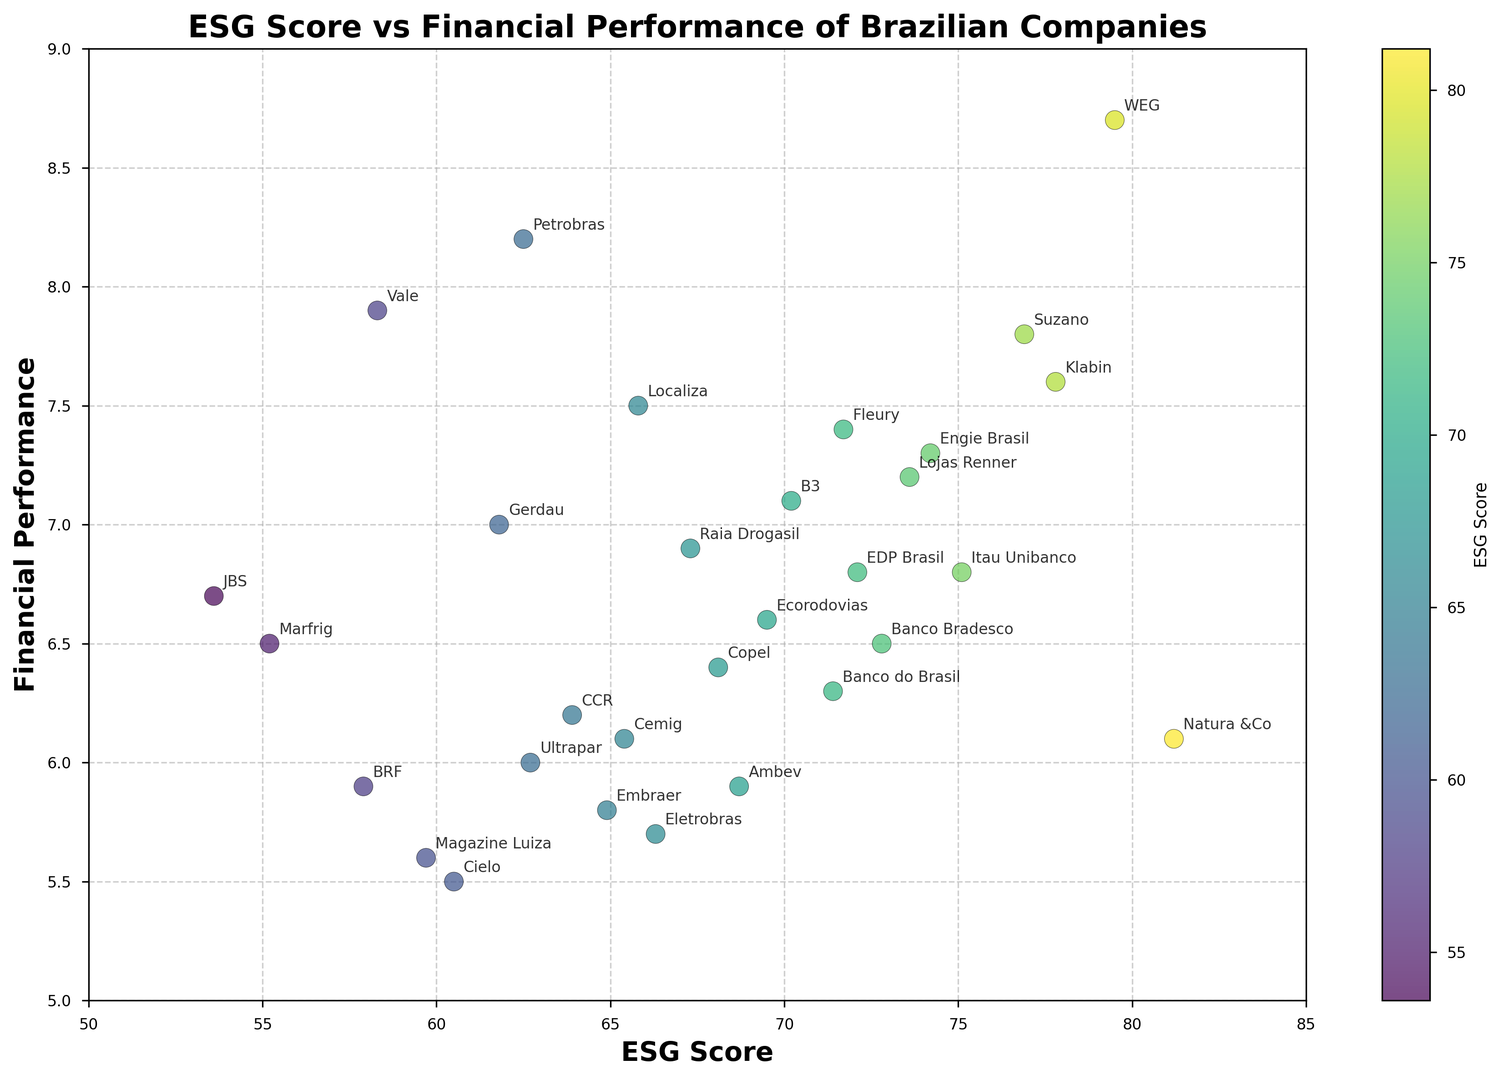What company has the highest ESG score? From the scatter plot, we can visually identify the company with the highest ESG score by looking at the upper part of the vertical axis (ESG Score). Natura &Co is at the top with an ESG score of 81.2.
Answer: Natura &Co What is the financial performance of the company with the lowest ESG score? By identifying the company with the lowest mark on the vertical axis (ESG Score), we can find that Marfrig has the lowest ESG score (55.2). From the scatter dot, its corresponding financial performance is around 6.5.
Answer: 6.5 Which company has a higher financial performance, WEG or Suzano? By looking at the positions of WEG and Suzano in the scatter plot, we can see that WEG is located higher than Suzano along the vertical axis (Financial Performance). WEG's financial performance is 8.7, while Suzano's is 7.8.
Answer: WEG What is the range of ESG scores among the companies depicted in the scatter plot? The range is calculated by identifying the highest and lowest ESG scores in the scatter plot. The highest score is from Natura &Co (81.2), and the lowest is from Marfrig (55.2). Subtracting the lowest score from the highest gives the range: 81.2 - 55.2 = 26.
Answer: 26 Are there more companies with an ESG score greater than 70 or a financial performance greater than 6? First, count the number of companies with an ESG score > 70 and then the companies with financial performance > 6. Companies with ESG > 70 are 11. Companies with financial performance > 6 are 19. Comparing these, there are more companies with a financial performance greater than 6.
Answer: Financial Performance Which company has an ESG score of around 73 and what is its financial performance? By locating the point around the ESG score of 73 on the scatter plot, we can identify Lojas Renner as the company with an ESG score of 73.6. Looking vertically, its financial performance is approximately 7.2.
Answer: Lojas Renner, 7.2 What is the approximate average ESG score of companies with financial performance over 7.5? First, identify the companies with financial performance > 7.5: Petrobras, Vale, WEG, Suzano, B3, Gerdau, Fleury, Klabin. Their ESG scores are 62.5, 58.3, 79.5, 76.9, 70.2, 61.8, 71.7, and 77.8 respectively. Calculate the average: (62.5 + 58.3 + 79.5 + 76.9 + 70.2 + 61.8 + 71.7 + 77.8) / 8 ≈ 69.85.
Answer: 69.85 Is the correlation between ESG score and financial performance positive, negative, or neutral? By observing the general trend in the scatter plot, we can see that there is a slight upward trend, indicating a positive correlation. Higher ESG scores tend to relate to better financial performance.
Answer: Positive Which company identifies close to the midpoint of the scatter plot? The midpoint of the scatter plot would be around the midway score of ESG (67.6) and financial performance (7.0). Closest to this point in the scatter plot is Ecorodovias with ESG 69.5 and financial performance 6.6.
Answer: Ecorodovias 